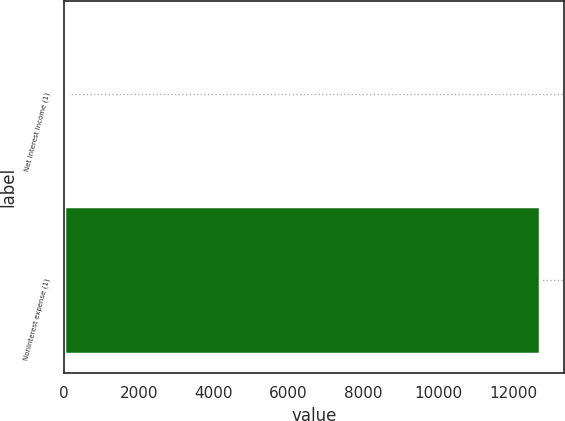Convert chart. <chart><loc_0><loc_0><loc_500><loc_500><bar_chart><fcel>Net interest income (1)<fcel>Noninterest expense (1)<nl><fcel>76<fcel>12714<nl></chart> 